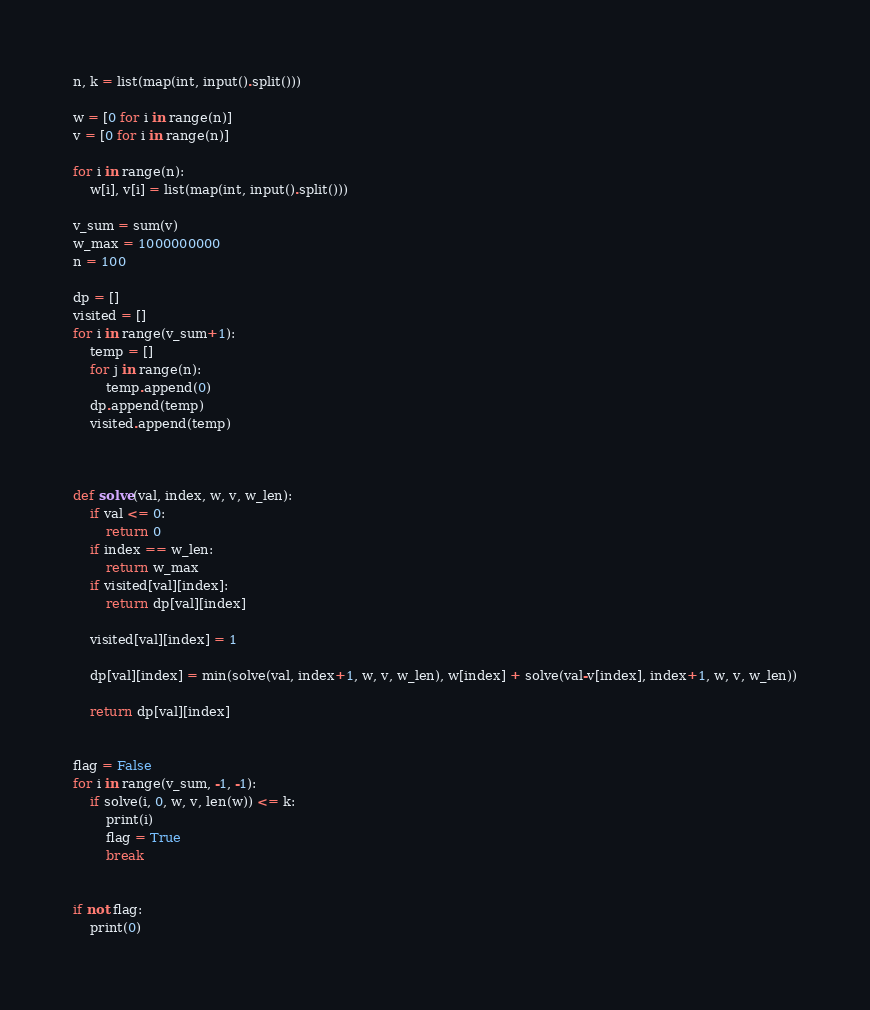<code> <loc_0><loc_0><loc_500><loc_500><_Python_>n, k = list(map(int, input().split()))

w = [0 for i in range(n)]
v = [0 for i in range(n)]

for i in range(n):
    w[i], v[i] = list(map(int, input().split()))

v_sum = sum(v)
w_max = 1000000000
n = 100

dp = []
visited = []
for i in range(v_sum+1):
    temp = []
    for j in range(n):
        temp.append(0)
    dp.append(temp)
    visited.append(temp)



def solve(val, index, w, v, w_len):
    if val <= 0:
        return 0
    if index == w_len:
        return w_max
    if visited[val][index]:
        return dp[val][index]

    visited[val][index] = 1

    dp[val][index] = min(solve(val, index+1, w, v, w_len), w[index] + solve(val-v[index], index+1, w, v, w_len))

    return dp[val][index]


flag = False
for i in range(v_sum, -1, -1):
    if solve(i, 0, w, v, len(w)) <= k:
        print(i)
        flag = True
        break


if not flag:
    print(0)
</code> 